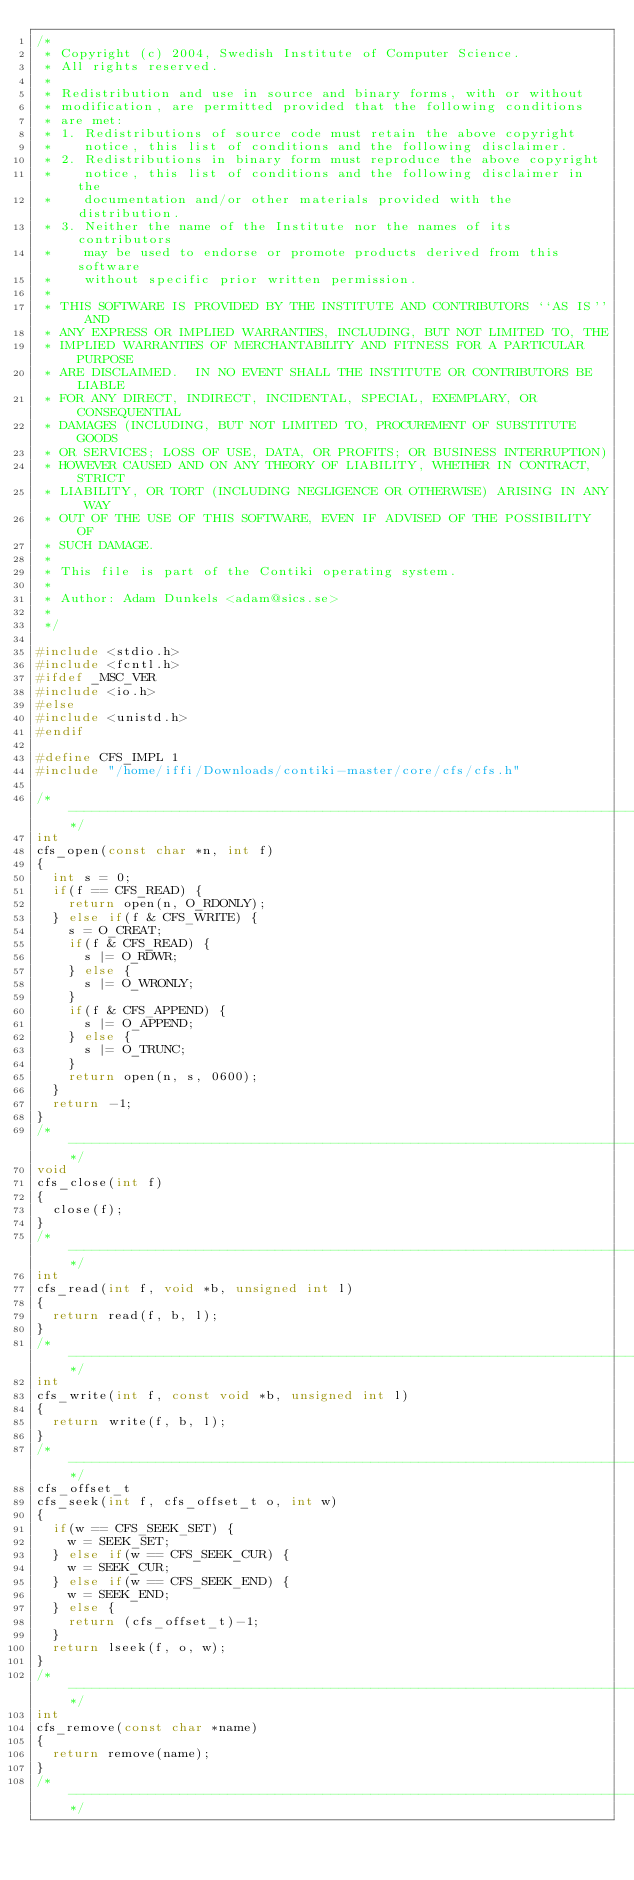Convert code to text. <code><loc_0><loc_0><loc_500><loc_500><_C_>/*
 * Copyright (c) 2004, Swedish Institute of Computer Science.
 * All rights reserved.
 *
 * Redistribution and use in source and binary forms, with or without
 * modification, are permitted provided that the following conditions
 * are met:
 * 1. Redistributions of source code must retain the above copyright
 *    notice, this list of conditions and the following disclaimer.
 * 2. Redistributions in binary form must reproduce the above copyright
 *    notice, this list of conditions and the following disclaimer in the
 *    documentation and/or other materials provided with the distribution.
 * 3. Neither the name of the Institute nor the names of its contributors
 *    may be used to endorse or promote products derived from this software
 *    without specific prior written permission.
 *
 * THIS SOFTWARE IS PROVIDED BY THE INSTITUTE AND CONTRIBUTORS ``AS IS'' AND
 * ANY EXPRESS OR IMPLIED WARRANTIES, INCLUDING, BUT NOT LIMITED TO, THE
 * IMPLIED WARRANTIES OF MERCHANTABILITY AND FITNESS FOR A PARTICULAR PURPOSE
 * ARE DISCLAIMED.  IN NO EVENT SHALL THE INSTITUTE OR CONTRIBUTORS BE LIABLE
 * FOR ANY DIRECT, INDIRECT, INCIDENTAL, SPECIAL, EXEMPLARY, OR CONSEQUENTIAL
 * DAMAGES (INCLUDING, BUT NOT LIMITED TO, PROCUREMENT OF SUBSTITUTE GOODS
 * OR SERVICES; LOSS OF USE, DATA, OR PROFITS; OR BUSINESS INTERRUPTION)
 * HOWEVER CAUSED AND ON ANY THEORY OF LIABILITY, WHETHER IN CONTRACT, STRICT
 * LIABILITY, OR TORT (INCLUDING NEGLIGENCE OR OTHERWISE) ARISING IN ANY WAY
 * OUT OF THE USE OF THIS SOFTWARE, EVEN IF ADVISED OF THE POSSIBILITY OF
 * SUCH DAMAGE.
 *
 * This file is part of the Contiki operating system.
 *
 * Author: Adam Dunkels <adam@sics.se>
 *
 */

#include <stdio.h>
#include <fcntl.h>
#ifdef _MSC_VER
#include <io.h>
#else
#include <unistd.h>
#endif

#define CFS_IMPL 1
#include "/home/iffi/Downloads/contiki-master/core/cfs/cfs.h"

/*---------------------------------------------------------------------------*/
int
cfs_open(const char *n, int f)
{
  int s = 0;
  if(f == CFS_READ) {
    return open(n, O_RDONLY);
  } else if(f & CFS_WRITE) {
    s = O_CREAT;
    if(f & CFS_READ) {
      s |= O_RDWR;
    } else {
      s |= O_WRONLY;
    }
    if(f & CFS_APPEND) {
      s |= O_APPEND;
    } else {
      s |= O_TRUNC;
    }
    return open(n, s, 0600);
  }
  return -1;
}
/*---------------------------------------------------------------------------*/
void
cfs_close(int f)
{
  close(f);
}
/*---------------------------------------------------------------------------*/
int
cfs_read(int f, void *b, unsigned int l)
{
  return read(f, b, l);
}
/*---------------------------------------------------------------------------*/
int
cfs_write(int f, const void *b, unsigned int l)
{
  return write(f, b, l);
}
/*---------------------------------------------------------------------------*/
cfs_offset_t
cfs_seek(int f, cfs_offset_t o, int w)
{
  if(w == CFS_SEEK_SET) {
    w = SEEK_SET;
  } else if(w == CFS_SEEK_CUR) {
    w = SEEK_CUR;
  } else if(w == CFS_SEEK_END) {
    w = SEEK_END;
  } else {
    return (cfs_offset_t)-1;
  }
  return lseek(f, o, w);
}
/*---------------------------------------------------------------------------*/
int
cfs_remove(const char *name)
{
  return remove(name);
}
/*---------------------------------------------------------------------------*/
</code> 